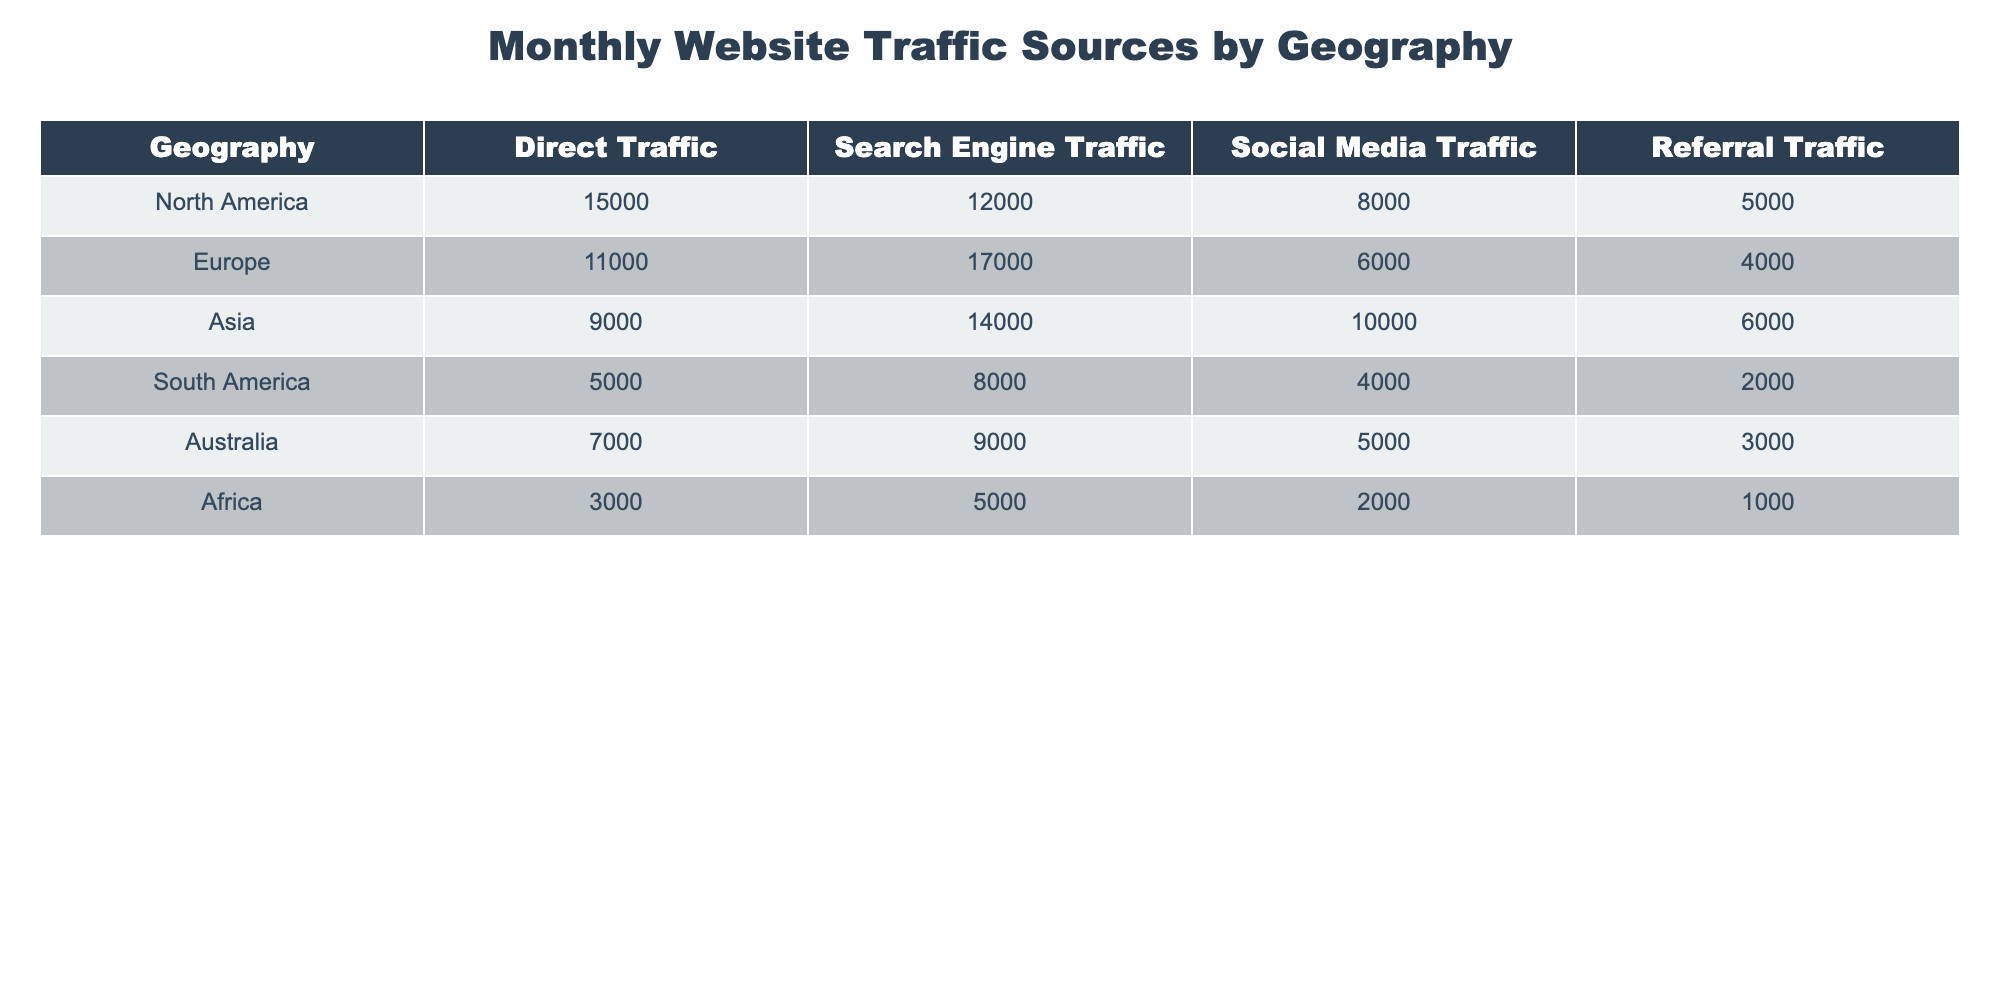What is the total Direct Traffic for Asia? In the table, the Direct Traffic for Asia is provided as 9000. Therefore, the total Direct Traffic for Asia is simply that value.
Answer: 9000 Which region has the highest Search Engine Traffic? Looking at the Search Engine Traffic values in the table, Europe has the highest number with 17000. All other regions have lower values.
Answer: Europe What is the difference in Social Media Traffic between North America and South America? North America has 8000 in Social Media Traffic while South America has 4000. The difference is calculated as 8000 - 4000 = 4000.
Answer: 4000 Does Africa have more Referral Traffic than South America? The Referral Traffic for Africa is 1000, while South America has 2000. Since 1000 is less than 2000, Africa does not have more.
Answer: No What is the average Direct Traffic across all regions? To find the average, sum all the Direct Traffic values (15000 + 11000 + 9000 + 5000 + 7000 + 3000 = 51000) and divide by the number of regions (6). Hence, the average is 51000 / 6 = 8500.
Answer: 8500 Which region has the lowest total traffic when all traffic sources are combined? First, calculate the total traffic for each region by summing all traffic types. For example, North America has 15000 + 12000 + 8000 + 5000 = 40000. After calculating, Africa has the lowest total of 11000.
Answer: Africa What is the total traffic for Europe? The total traffic for Europe can be calculated by summing all types of traffic: 11000 + 17000 + 6000 + 4000 = 40000. Hence, the total for Europe is 40000.
Answer: 40000 Is Social Media Traffic in Asia greater than the combined Referral Traffic in Africa and South America? The Social Media Traffic in Asia is 10000. The combined Referral Traffic in Africa and South America is 1000 + 2000 = 3000. Since 10000 is greater than 3000, the statement is true.
Answer: Yes 